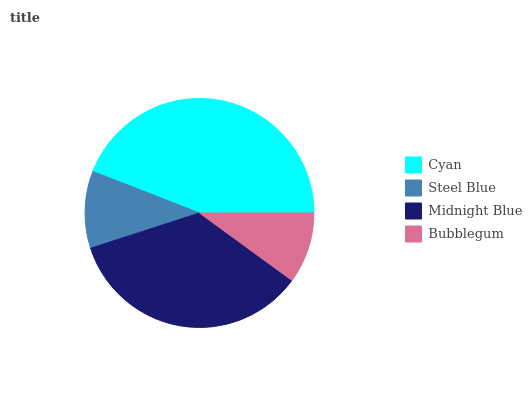Is Bubblegum the minimum?
Answer yes or no. Yes. Is Cyan the maximum?
Answer yes or no. Yes. Is Steel Blue the minimum?
Answer yes or no. No. Is Steel Blue the maximum?
Answer yes or no. No. Is Cyan greater than Steel Blue?
Answer yes or no. Yes. Is Steel Blue less than Cyan?
Answer yes or no. Yes. Is Steel Blue greater than Cyan?
Answer yes or no. No. Is Cyan less than Steel Blue?
Answer yes or no. No. Is Midnight Blue the high median?
Answer yes or no. Yes. Is Steel Blue the low median?
Answer yes or no. Yes. Is Bubblegum the high median?
Answer yes or no. No. Is Midnight Blue the low median?
Answer yes or no. No. 